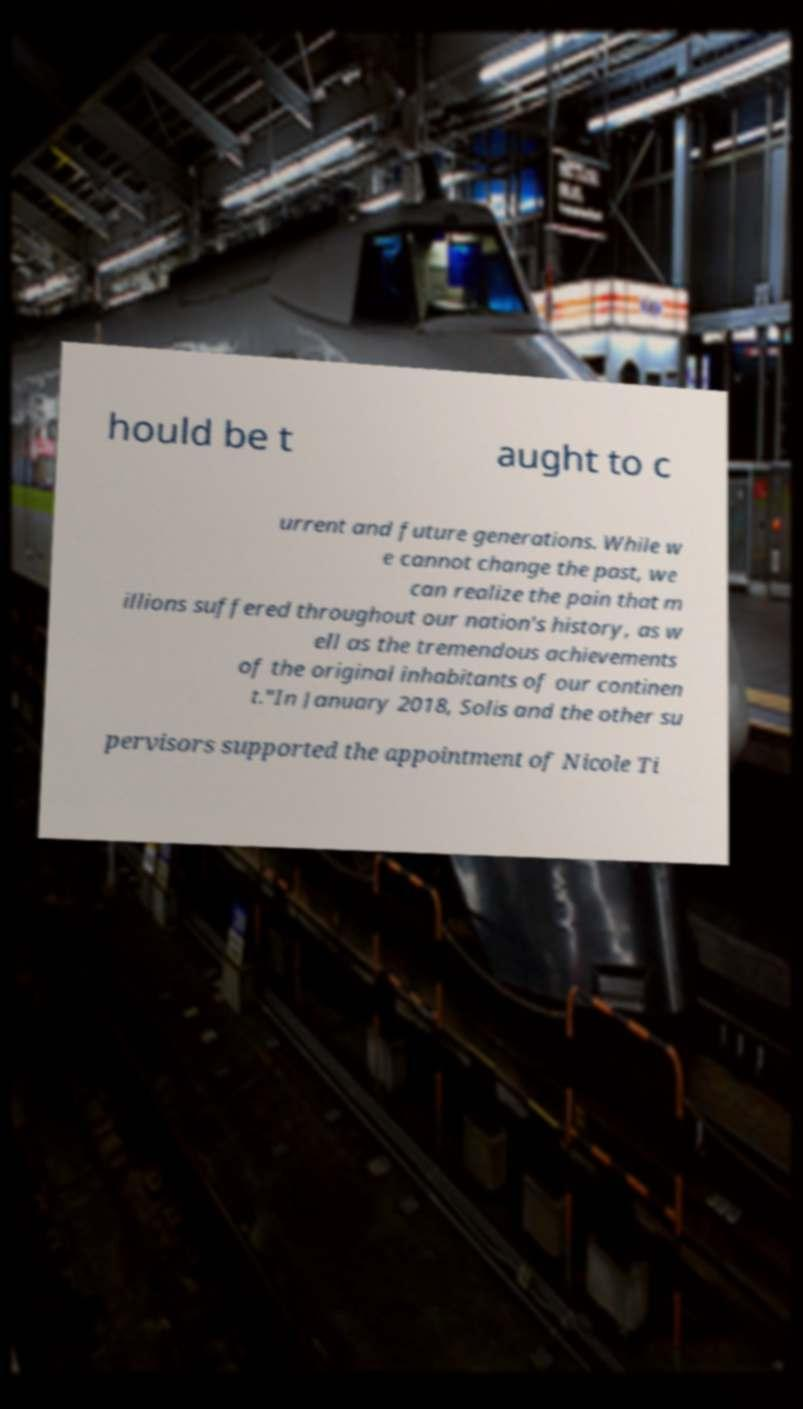Can you read and provide the text displayed in the image?This photo seems to have some interesting text. Can you extract and type it out for me? hould be t aught to c urrent and future generations. While w e cannot change the past, we can realize the pain that m illions suffered throughout our nation's history, as w ell as the tremendous achievements of the original inhabitants of our continen t."In January 2018, Solis and the other su pervisors supported the appointment of Nicole Ti 